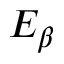Convert formula to latex. <formula><loc_0><loc_0><loc_500><loc_500>E _ { \beta }</formula> 